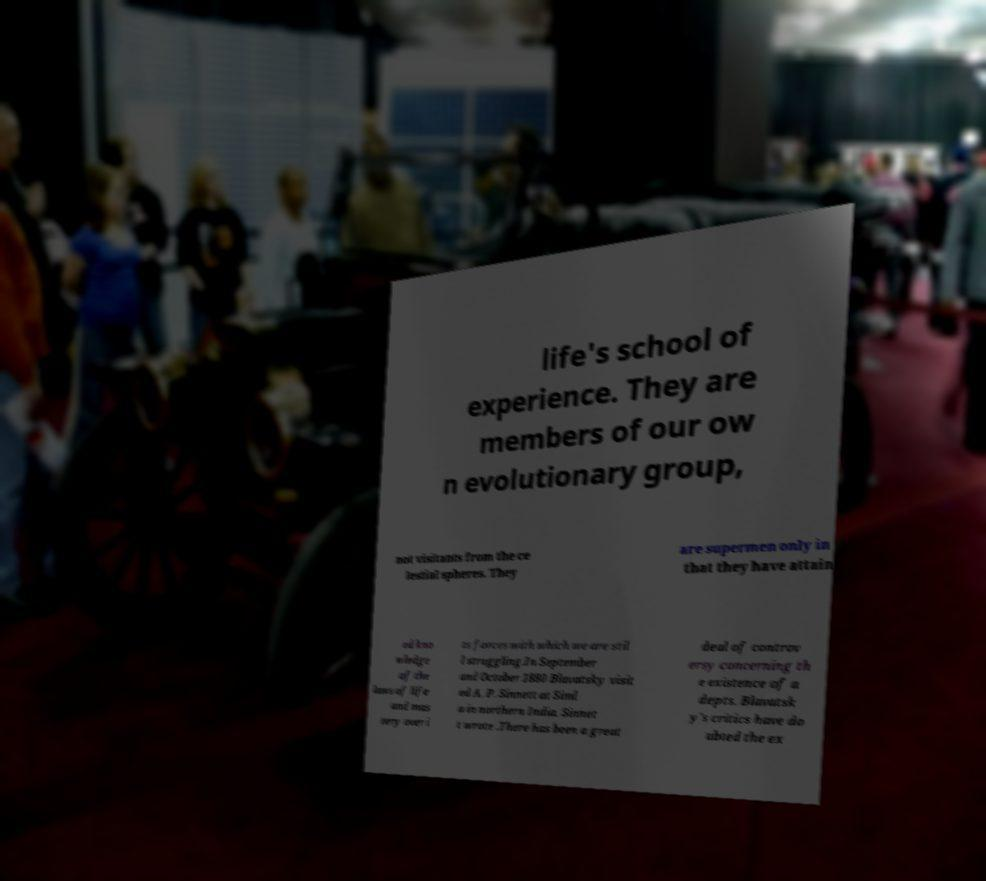What messages or text are displayed in this image? I need them in a readable, typed format. life's school of experience. They are members of our ow n evolutionary group, not visitants from the ce lestial spheres. They are supermen only in that they have attain ed kno wledge of the laws of life and mas tery over i ts forces with which we are stil l struggling.In September and October 1880 Blavatsky visit ed A. P. Sinnett at Siml a in northern India. Sinnet t wrote .There has been a great deal of controv ersy concerning th e existence of a depts. Blavatsk y's critics have do ubted the ex 